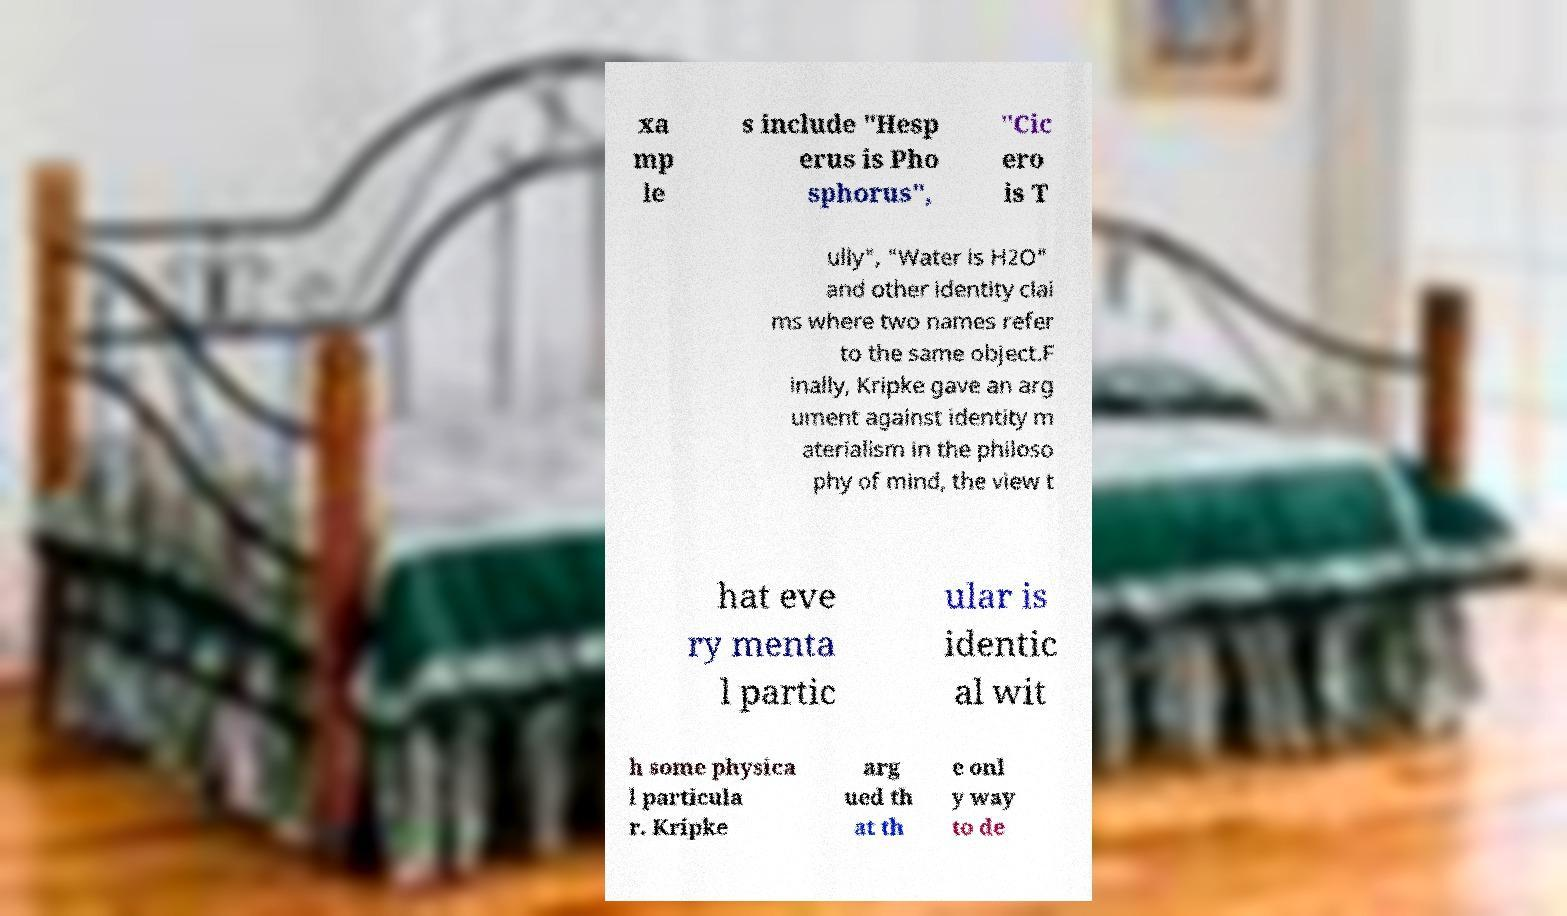Could you assist in decoding the text presented in this image and type it out clearly? xa mp le s include "Hesp erus is Pho sphorus", "Cic ero is T ully", "Water is H2O" and other identity clai ms where two names refer to the same object.F inally, Kripke gave an arg ument against identity m aterialism in the philoso phy of mind, the view t hat eve ry menta l partic ular is identic al wit h some physica l particula r. Kripke arg ued th at th e onl y way to de 